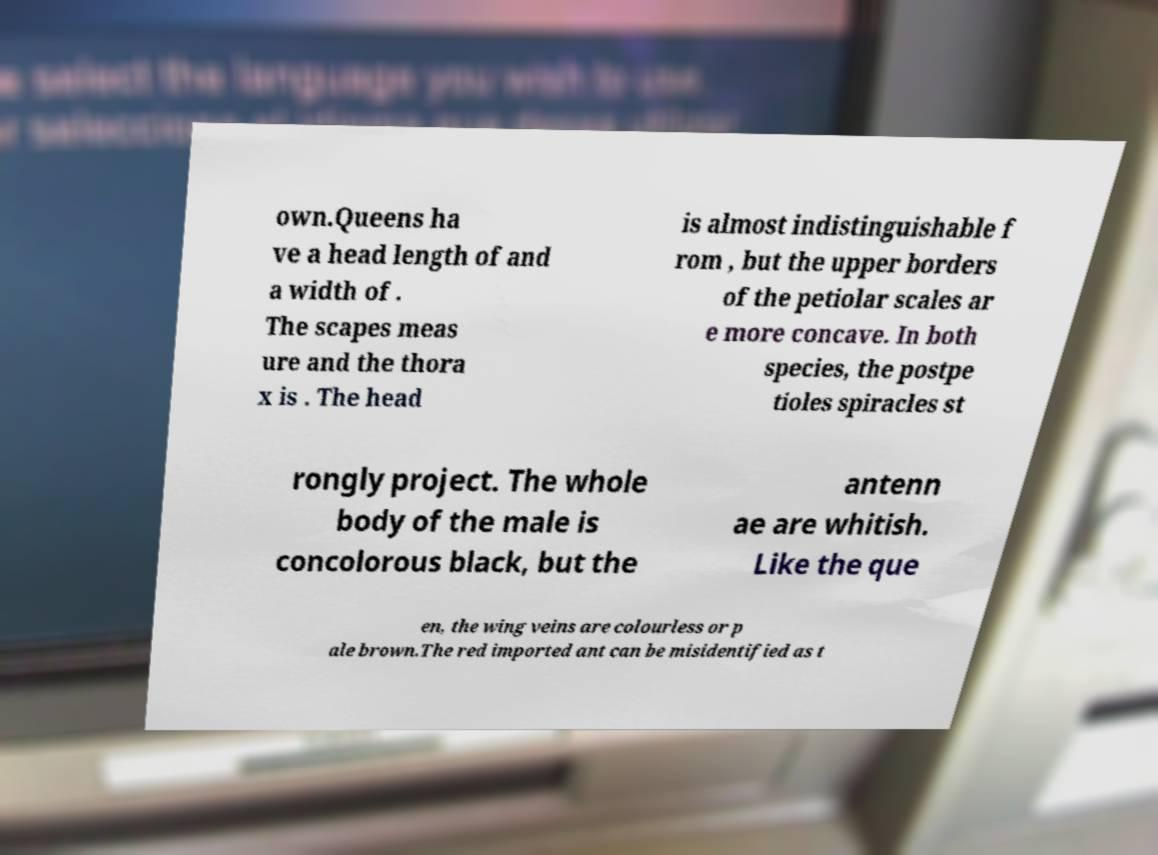Can you read and provide the text displayed in the image?This photo seems to have some interesting text. Can you extract and type it out for me? own.Queens ha ve a head length of and a width of . The scapes meas ure and the thora x is . The head is almost indistinguishable f rom , but the upper borders of the petiolar scales ar e more concave. In both species, the postpe tioles spiracles st rongly project. The whole body of the male is concolorous black, but the antenn ae are whitish. Like the que en, the wing veins are colourless or p ale brown.The red imported ant can be misidentified as t 